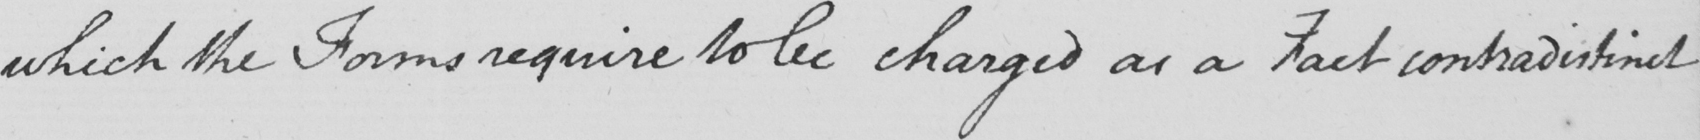What does this handwritten line say? which the Forms require to be charged as a Fact contradistinct 